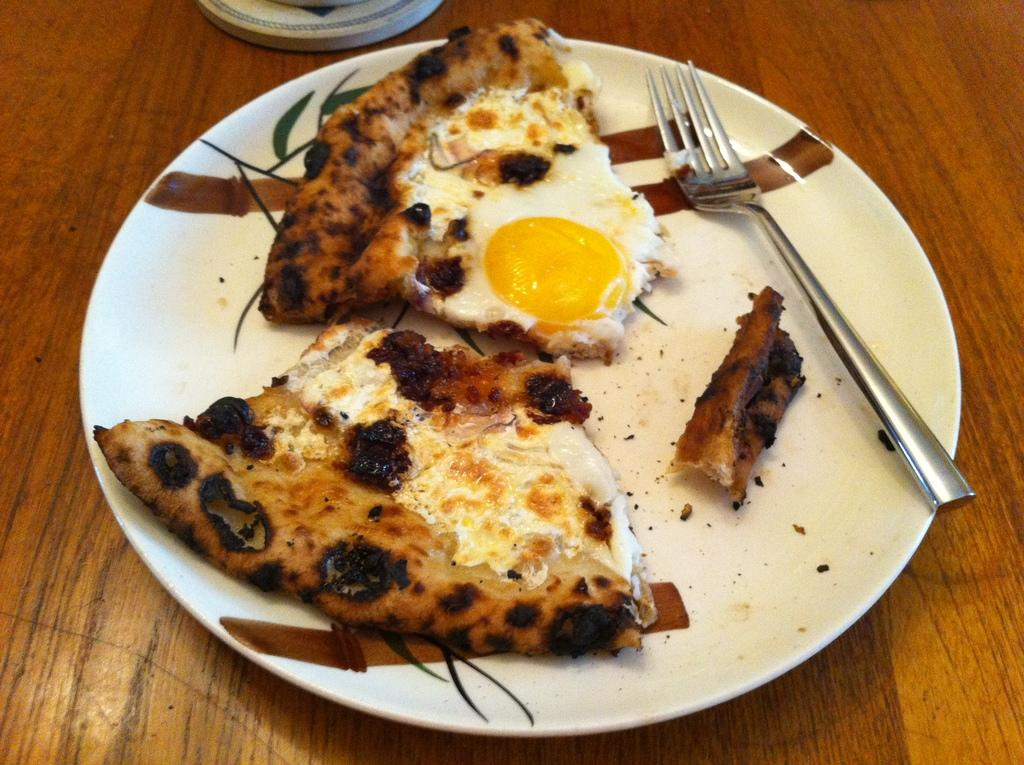What color is the plate that is visible in the image? The plate is white in color. What utensil is placed on the plate in the image? There is a fork on the plate. What is on top of the plate in the image? There are pieces of food on the plate. Can you describe the unspecified object in the image? Unfortunately, the description of the unspecified object is not provided in the facts. How does the plate wash itself in the image? The plate does not wash itself in the image; it is stationary and not engaged in any activity. 